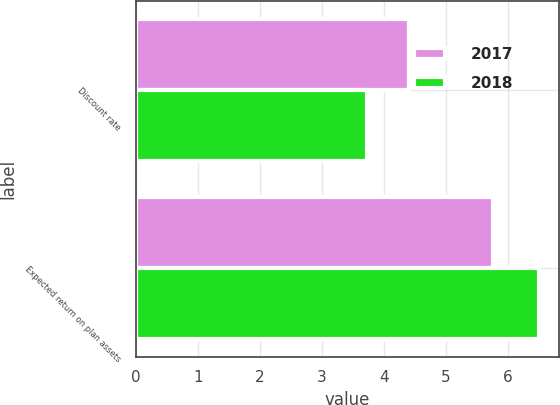Convert chart to OTSL. <chart><loc_0><loc_0><loc_500><loc_500><stacked_bar_chart><ecel><fcel>Discount rate<fcel>Expected return on plan assets<nl><fcel>2017<fcel>4.41<fcel>5.75<nl><fcel>2018<fcel>3.73<fcel>6.5<nl></chart> 